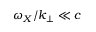Convert formula to latex. <formula><loc_0><loc_0><loc_500><loc_500>\omega _ { X } / k _ { \perp } \ll c</formula> 